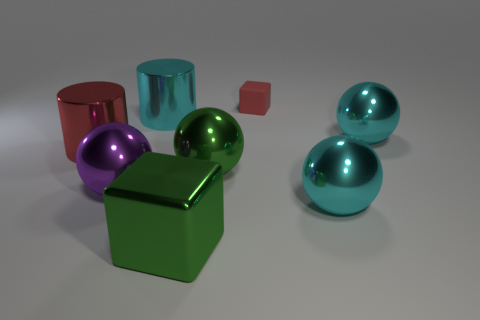Are there more tiny red cubes than large green objects?
Offer a terse response. No. Is the shape of the red object that is left of the red matte thing the same as  the big purple thing?
Offer a very short reply. No. What number of metallic objects are things or red cubes?
Ensure brevity in your answer.  7. Are there any large things made of the same material as the large cyan cylinder?
Provide a short and direct response. Yes. What material is the large cyan cylinder?
Provide a succinct answer. Metal. There is a green object that is behind the ball on the left side of the cylinder that is right of the large red cylinder; what shape is it?
Make the answer very short. Sphere. Is the number of cylinders that are in front of the large purple object greater than the number of small brown spheres?
Ensure brevity in your answer.  No. Do the large red shiny thing and the green metal thing to the right of the metallic cube have the same shape?
Your response must be concise. No. There is another metallic thing that is the same color as the tiny thing; what is its shape?
Ensure brevity in your answer.  Cylinder. How many rubber cubes are in front of the big cyan shiny object left of the green metal object that is behind the large purple shiny object?
Make the answer very short. 0. 